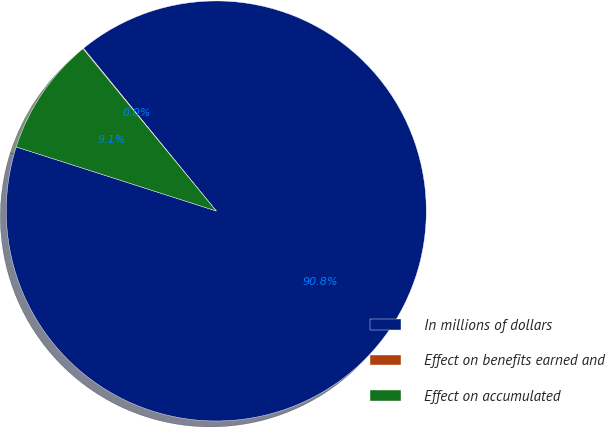Convert chart. <chart><loc_0><loc_0><loc_500><loc_500><pie_chart><fcel>In millions of dollars<fcel>Effect on benefits earned and<fcel>Effect on accumulated<nl><fcel>90.83%<fcel>0.05%<fcel>9.12%<nl></chart> 